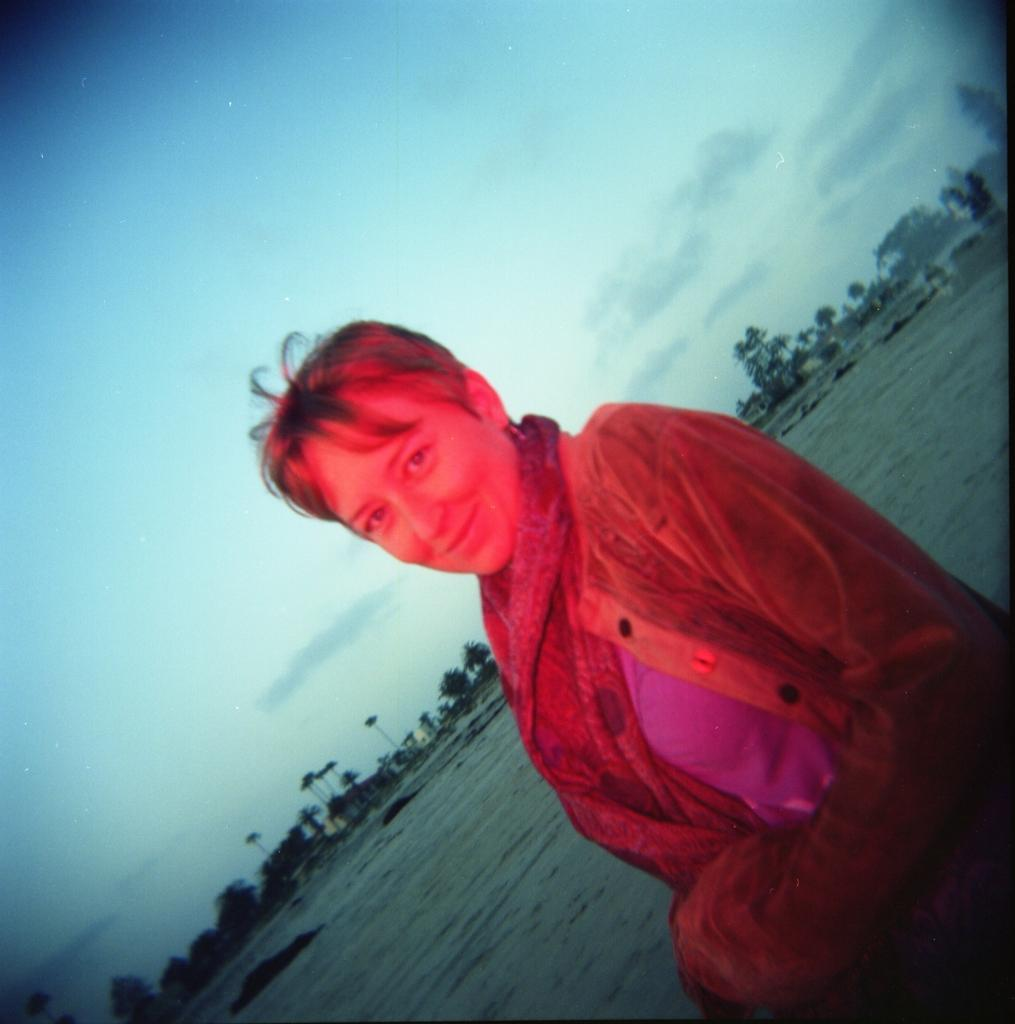Who is present in the image? There is a woman in the image. What is the woman wearing? The woman is wearing a jacket. What is the woman's facial expression? The woman is smiling. What can be seen in the background of the image? There are trees, clouds, and the sky visible in the background of the image. What direction is the pan moving in the image? There is no pan present in the image. How does the earthquake affect the woman in the image? There is no earthquake present in the image; the woman is simply smiling. 